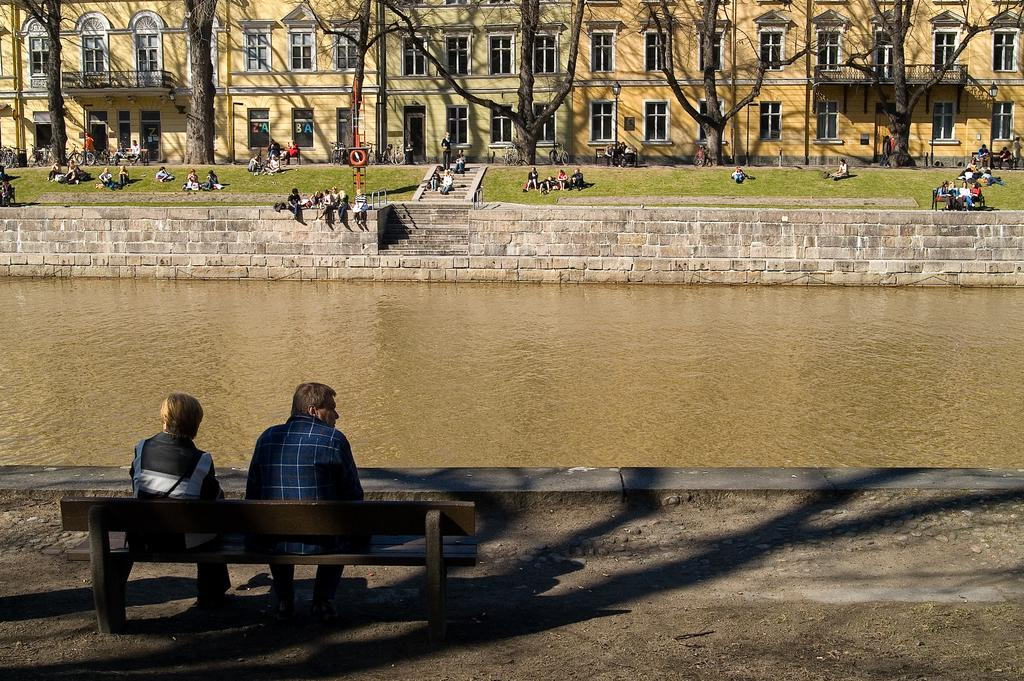How many people are sitting on the bench in the image? There are two people sitting on the bench in the image. What is the location of the bench in relation to the lake? The bench is near a lake. What other structures can be seen in the image? There is a building visible in the image. What type of natural environment is present in the image? Trees are present in the image. How many people are sitting near the lake in total? There are many people sitting near the lake in the image. What type of wound can be seen on the person sitting on the bench? There is no visible wound on any person in the image. What is the argument about that is happening near the lake? There is no argument present in the image; people are simply sitting near the lake. 